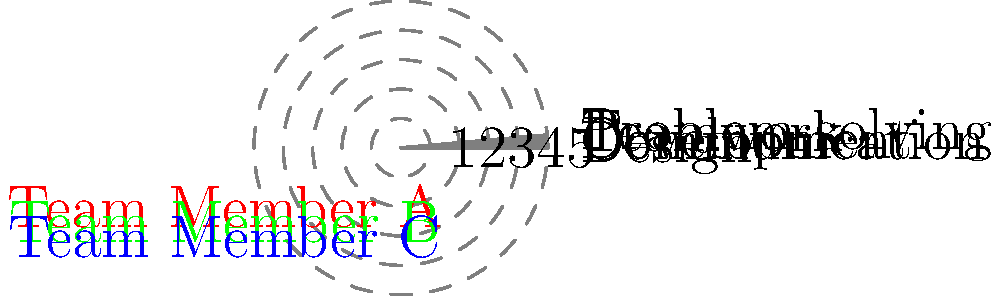As a strategic planner, you are tasked with analyzing the skills of three team members using a radar chart. The chart compares their abilities in Design, Development, Communication, Problem-solving, and Teamwork on a scale of 1 to 5. Which team member would be the most suitable to lead a project that requires strong communication and problem-solving skills? To determine the most suitable team member for leading a project that requires strong communication and problem-solving skills, we need to analyze the radar chart for each team member's scores in these two categories:

1. Identify the axes for Communication and Problem-solving on the radar chart.
2. Compare the scores for each team member on these two axes:

   Team Member A (Red):
   - Communication: 5
   - Problem-solving: 2

   Team Member B (Green):
   - Communication: 2
   - Problem-solving: 4

   Team Member C (Blue):
   - Communication: 4
   - Problem-solving: 3

3. Calculate the combined score for Communication and Problem-solving for each team member:
   - Team Member A: 5 + 2 = 7
   - Team Member B: 2 + 4 = 6
   - Team Member C: 4 + 3 = 7

4. Compare the combined scores:
   Team Members A and C have the highest combined score of 7.

5. Consider the balance between the two skills:
   Team Member C has a more balanced score (4 in Communication and 3 in Problem-solving) compared to Team Member A (5 in Communication but only 2 in Problem-solving).

Therefore, Team Member C would be the most suitable to lead a project requiring strong communication and problem-solving skills due to their balanced and high scores in both areas.
Answer: Team Member C 